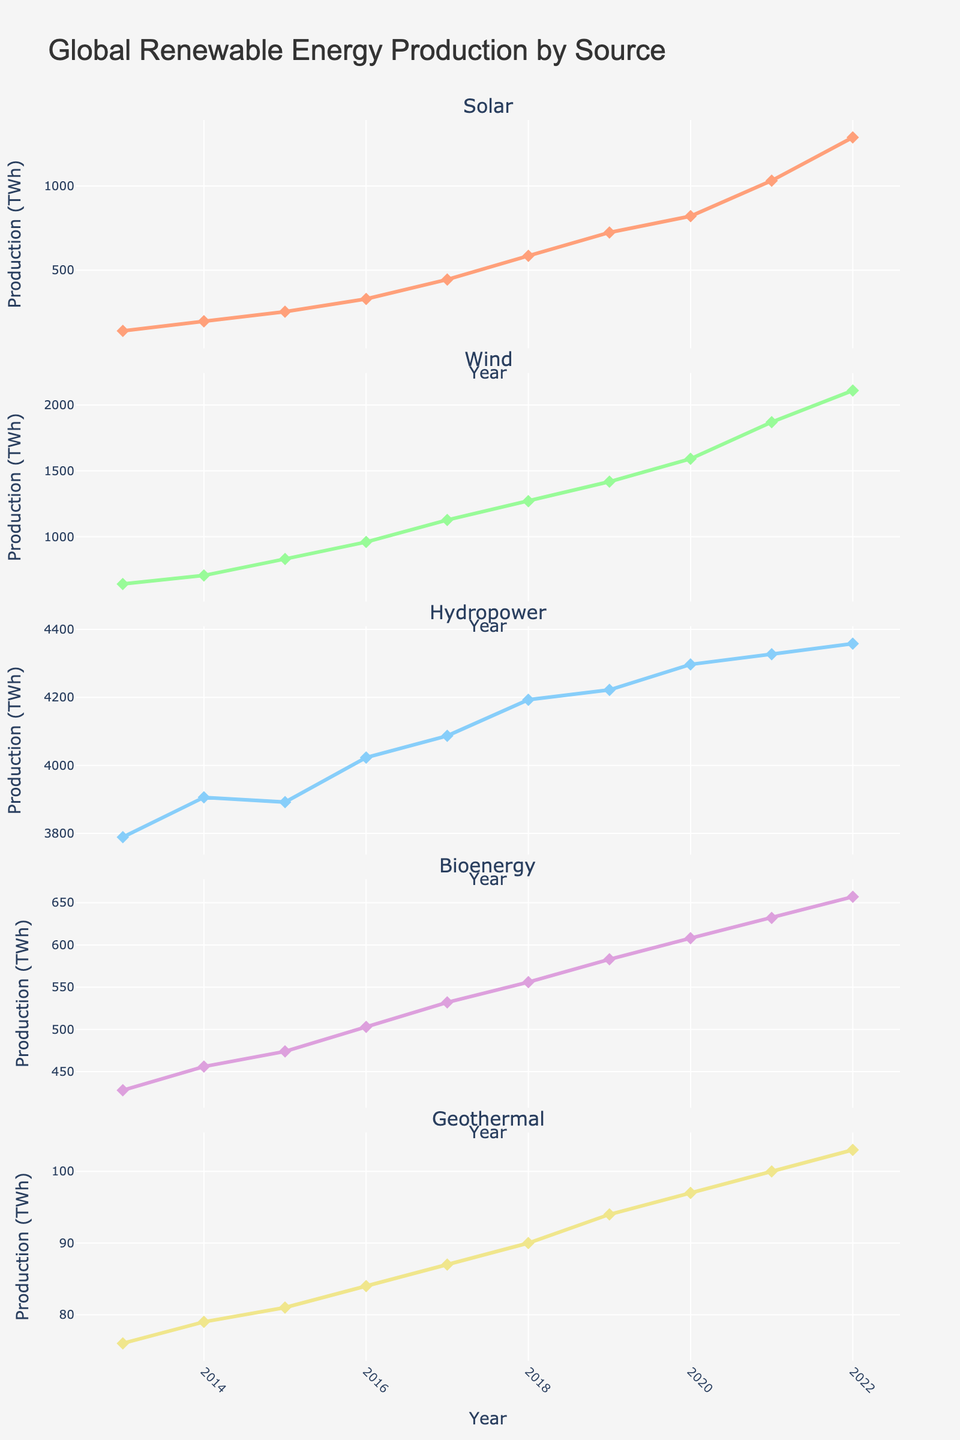How many political affiliations are represented in the figures? Count the number of unique political affiliations labeled on the x-axis in any of the subplot as they are consistently represented across each plot. There are: Republican, Independent, Democrat, Libertarian, Green Party.
Answer: 5 Which political affiliation shows the highest percentage for Comprehensive Education? Look at the Comprehensive Education subplot and identify which political party has the highest bar. Green Party shows an 80% preference for Comprehensive Education.
Answer: Green Party What is the total percentage of Republicans who support either Abstinence Only or No Sex Ed? Add the percentages for Abstinence Only (45%) and No Sex Ed (15%) within the Republican subplot. 45 + 15 = 60%.
Answer: 60% Who supports Parental Opt-Out more: Republicans or Democrats? Compare the heights of the bars for Parental Opt-Out for both Republicans (10%) and Democrats (15%). Democrats show higher support.
Answer: Democrats Which political affiliation shows the least support for Abstinence Only? In the Abstinence Only subplot, identify which political party has the lowest bar. Green Party has the lowest bar with 5%.
Answer: Green Party What is the average support for Comprehensive Education across all political affiliations? Add the values for Comprehensive Education for each political affiliation and divide by the number of affiliations: (30 + 50 + 70 + 45 + 80) / 5 = 55%.
Answer: 55% Do Independents or Libertarians show more support for No Sex Ed? Compare the heights of the bars for No Sex Ed for Independents (5%) and Libertarians (25%). Libertarians show more support.
Answer: Libertarians Among the listed political affiliations, which one has the most diverse opinion on sex education content? Identify the political affiliation whose subplots show a wide spread across different categories. Libertarians have significant percentages in multiple categories: Abstinence Only (20%), Comprehensive Education (45%), No Sex Ed (25%), and Parental Opt-Out (10%).
Answer: Libertarians Which two political affiliations have the same percentage for 'No Sex Ed' and what is that percentage? Look at the No Sex Ed subplot and find the political affiliations that have the same bar height. Independents and Democrats both show 5%.
Answer: Independents and Democrats at 5% 